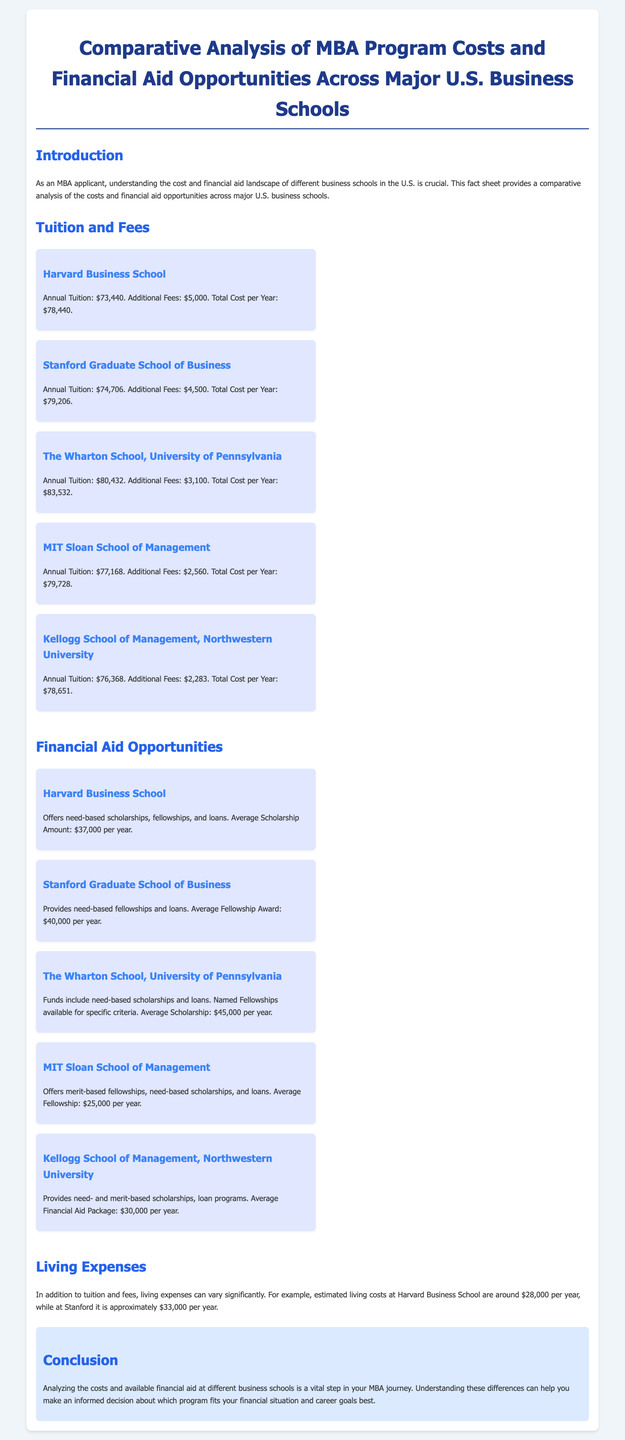What is the total cost per year for Harvard Business School? The total cost per year is explicitly stated in the document as $78,440.
Answer: $78,440 What is the average scholarship amount at The Wharton School? The average scholarship amount is mentioned as $45,000 per year for The Wharton School.
Answer: $45,000 Which school offers the highest annual tuition? The document lists the annual tuition for each school, and The Wharton School has the highest at $80,432.
Answer: The Wharton School What type of financial aid does MIT Sloan offer? MIT Sloan offers merit-based fellowships, need-based scholarships, and loans according to the document.
Answer: Merit-based fellowships What are the estimated living expenses at Stanford Graduate School of Business? The document provides estimated living costs of $33,000 per year for Stanford.
Answer: $33,000 Which business school has the lowest additional fees? The document states that MIT Sloan has the lowest additional fees at $2,560.
Answer: $2,560 What is the average financial aid package offered by Kellogg? The average financial aid package at Kellogg is stated as $30,000 per year.
Answer: $30,000 How much is the average fellowship award at Stanford? The fellowship award at Stanford for the graduate program is noted as $40,000 per year.
Answer: $40,000 What is a vital step in the MBA journey according to the conclusion? The document emphasizes that analyzing costs and available financial aid is a vital step.
Answer: Analyzing costs and financial aid 